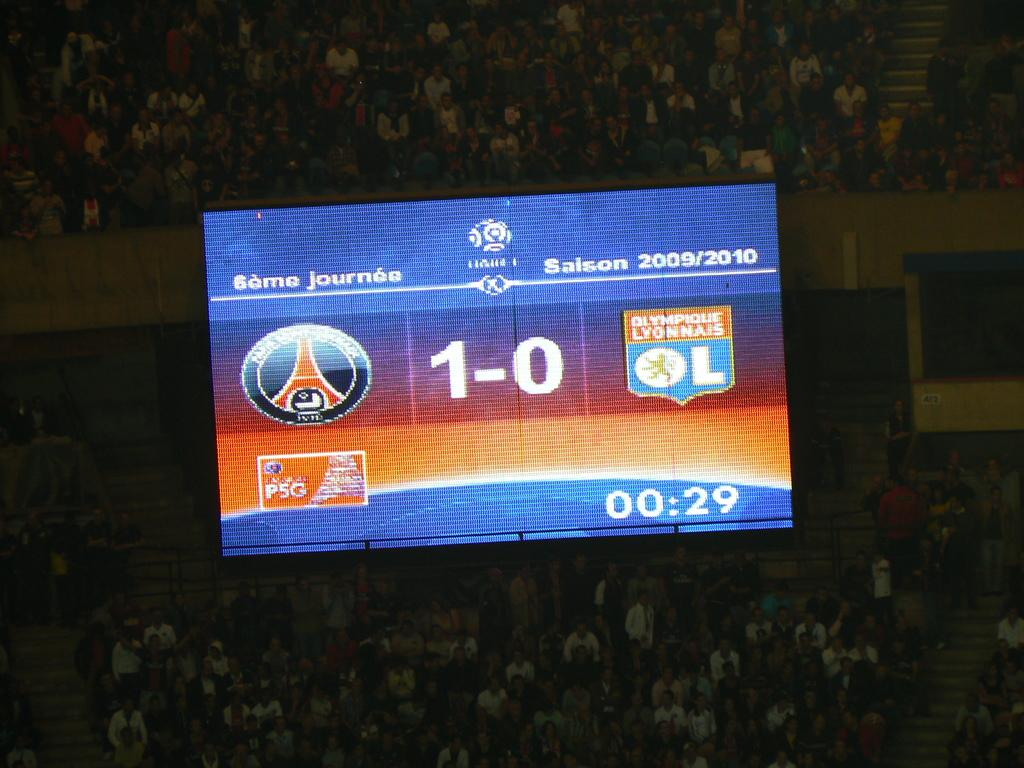<image>
Relay a brief, clear account of the picture shown. The score of an indoor sporting event is shown as 1-0 on the lit up scoreboard. 